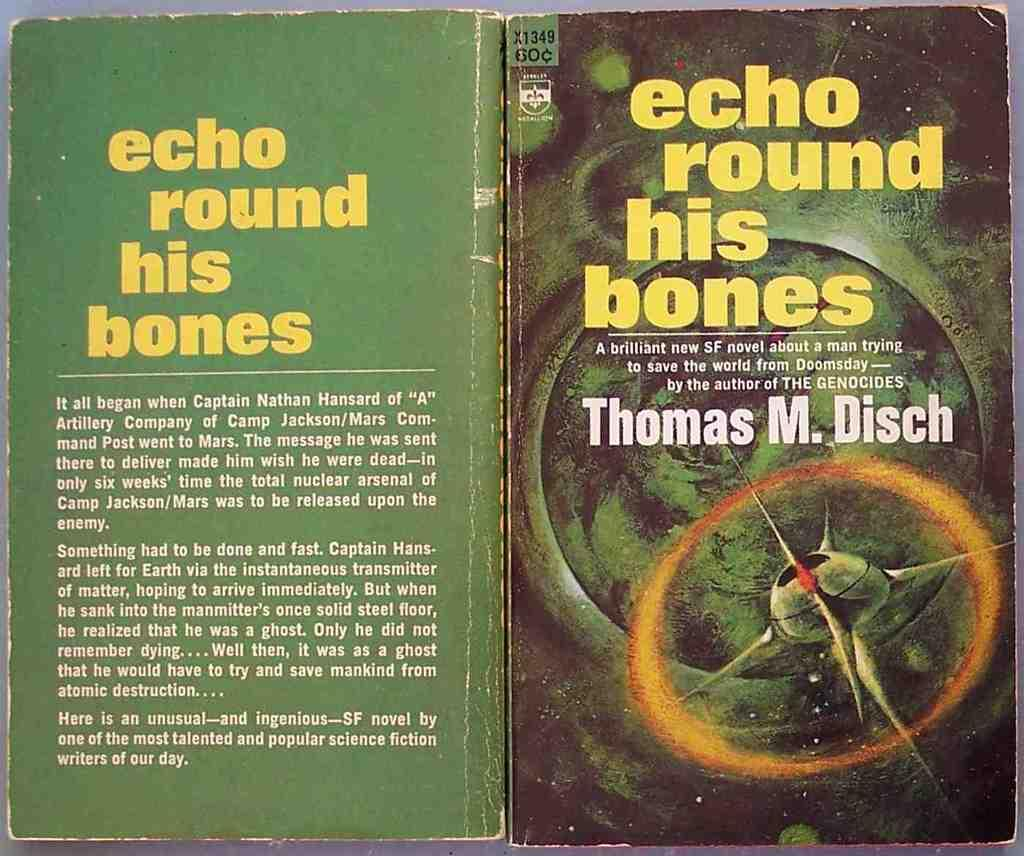Provide a one-sentence caption for the provided image. old book opened up, echo round his bones by thomas m disch. 